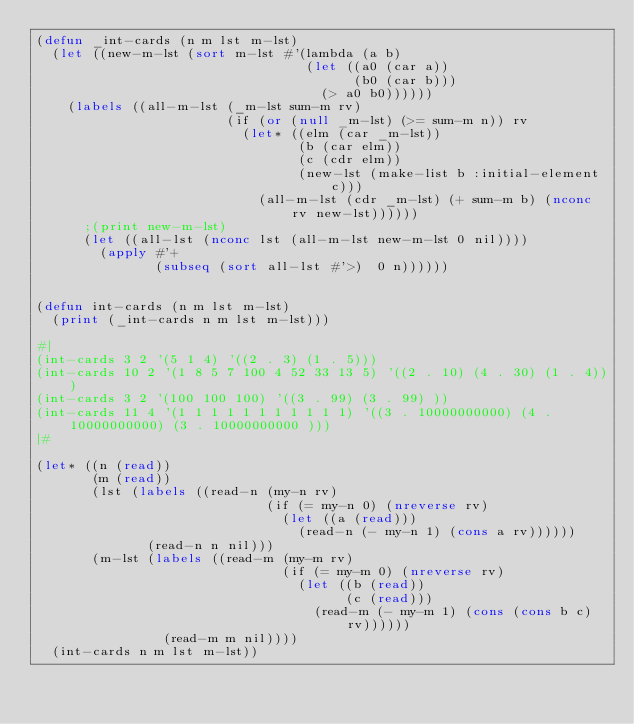Convert code to text. <code><loc_0><loc_0><loc_500><loc_500><_Lisp_>(defun _int-cards (n m lst m-lst)
  (let ((new-m-lst (sort m-lst #'(lambda (a b) 
                                  (let ((a0 (car a))
                                        (b0 (car b)))
                                    (> a0 b0))))))
    (labels ((all-m-lst (_m-lst sum-m rv)
                        (if (or (null _m-lst) (>= sum-m n)) rv
                          (let* ((elm (car _m-lst))
                                 (b (car elm))
                                 (c (cdr elm))
                                 (new-lst (make-list b :initial-element c)))
                            (all-m-lst (cdr _m-lst) (+ sum-m b) (nconc rv new-lst))))))
      ;(print new-m-lst)
      (let ((all-lst (nconc lst (all-m-lst new-m-lst 0 nil))))
        (apply #'+
               (subseq (sort all-lst #'>)  0 n))))))


(defun int-cards (n m lst m-lst)
  (print (_int-cards n m lst m-lst)))

#|
(int-cards 3 2 '(5 1 4) '((2 . 3) (1 . 5)))
(int-cards 10 2 '(1 8 5 7 100 4 52 33 13 5) '((2 . 10) (4 . 30) (1 . 4)))
(int-cards 3 2 '(100 100 100) '((3 . 99) (3 . 99) ))
(int-cards 11 4 '(1 1 1 1 1 1 1 1 1 1 1) '((3 . 10000000000) (4 . 10000000000) (3 . 10000000000 )))
|#

(let* ((n (read))
       (m (read))
       (lst (labels ((read-n (my-n rv)
                             (if (= my-n 0) (nreverse rv)
                               (let ((a (read)))
                                 (read-n (- my-n 1) (cons a rv))))))
              (read-n n nil)))
       (m-lst (labels ((read-m (my-m rv)
                               (if (= my-m 0) (nreverse rv)
                                 (let ((b (read))
                                       (c (read)))
                                   (read-m (- my-m 1) (cons (cons b c) rv))))))
                (read-m m nil))))
  (int-cards n m lst m-lst))

</code> 